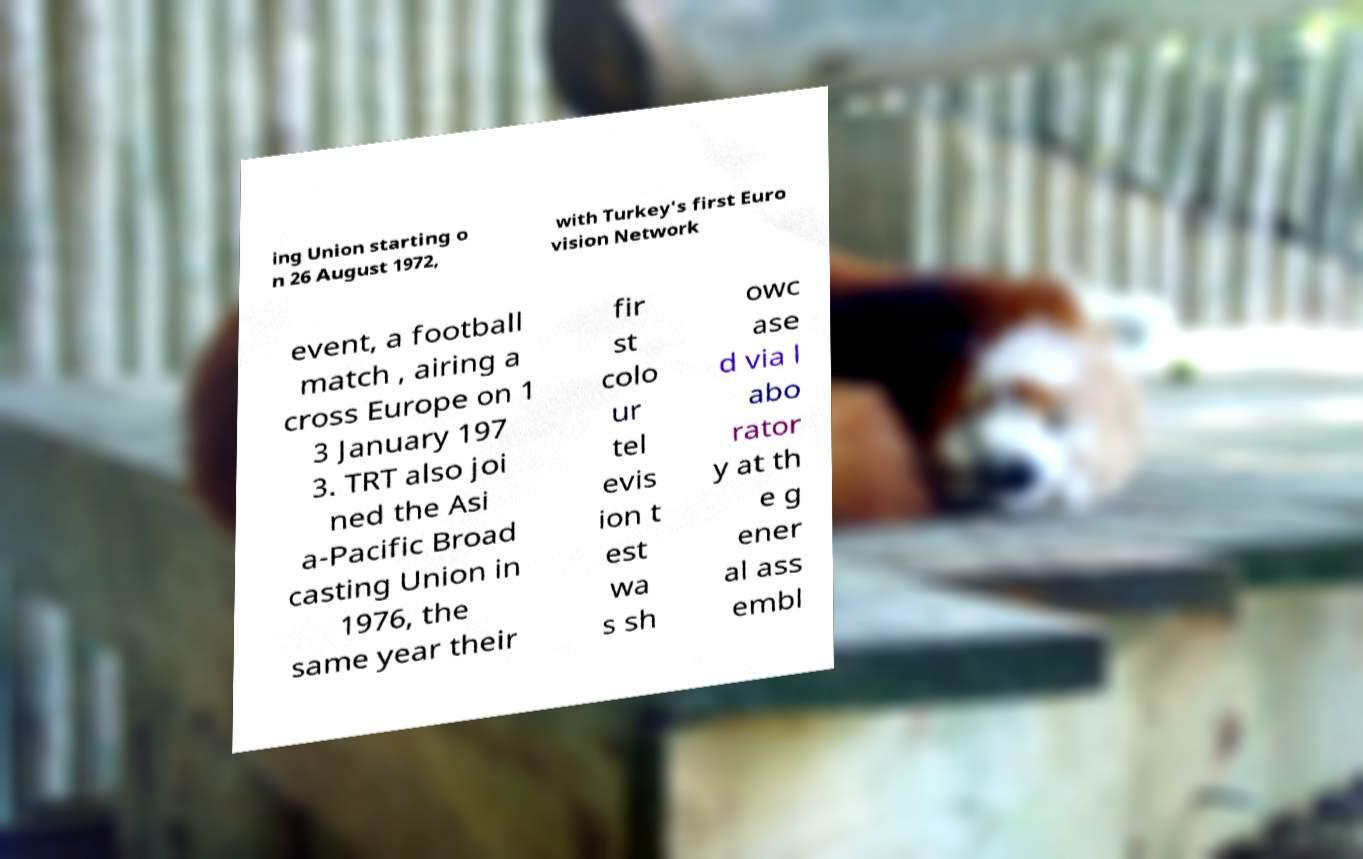I need the written content from this picture converted into text. Can you do that? ing Union starting o n 26 August 1972, with Turkey's first Euro vision Network event, a football match , airing a cross Europe on 1 3 January 197 3. TRT also joi ned the Asi a-Pacific Broad casting Union in 1976, the same year their fir st colo ur tel evis ion t est wa s sh owc ase d via l abo rator y at th e g ener al ass embl 